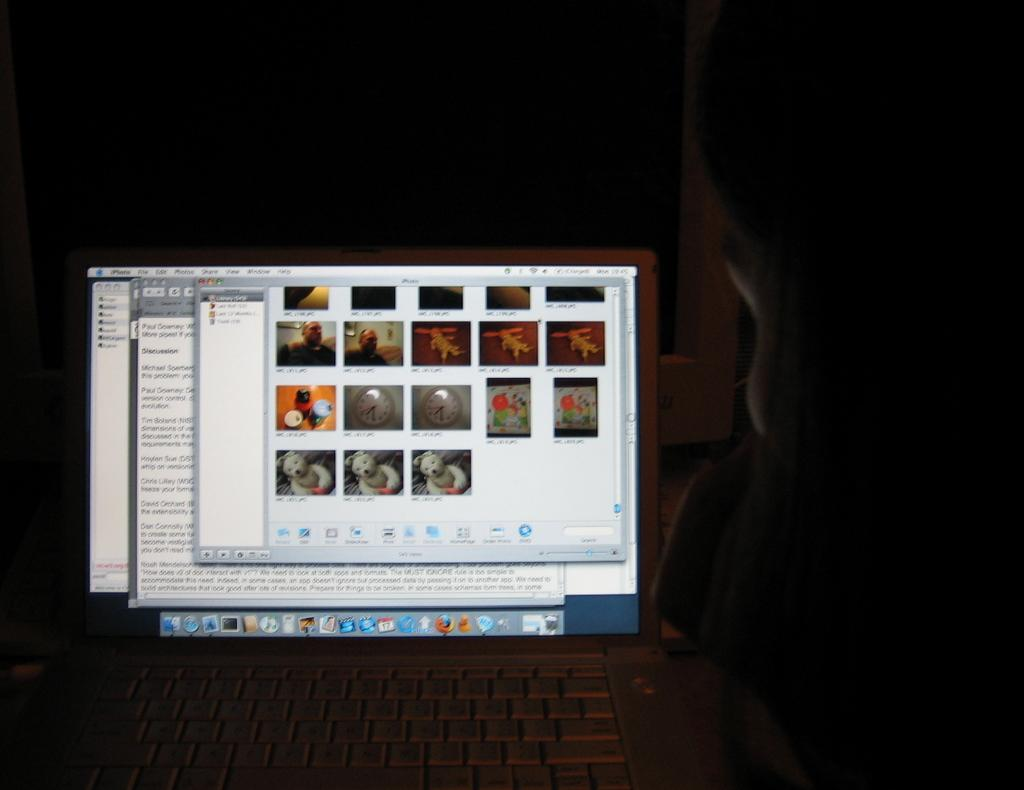What is the person in the image doing? The person is working with a laptop. What object is the person using in the image? The person is using a laptop. What can be seen behind the laptop in the image? There is a wall visible behind the laptop. What type of brick is the person using to build a structure in the image? There is no brick or structure building activity present in the image. How many daughters does the person in the image have? There is no information about the person's daughters in the image. How many women are present in the image? There is only one person visible in the image, and it is not specified whether the person is a man or a woman. 